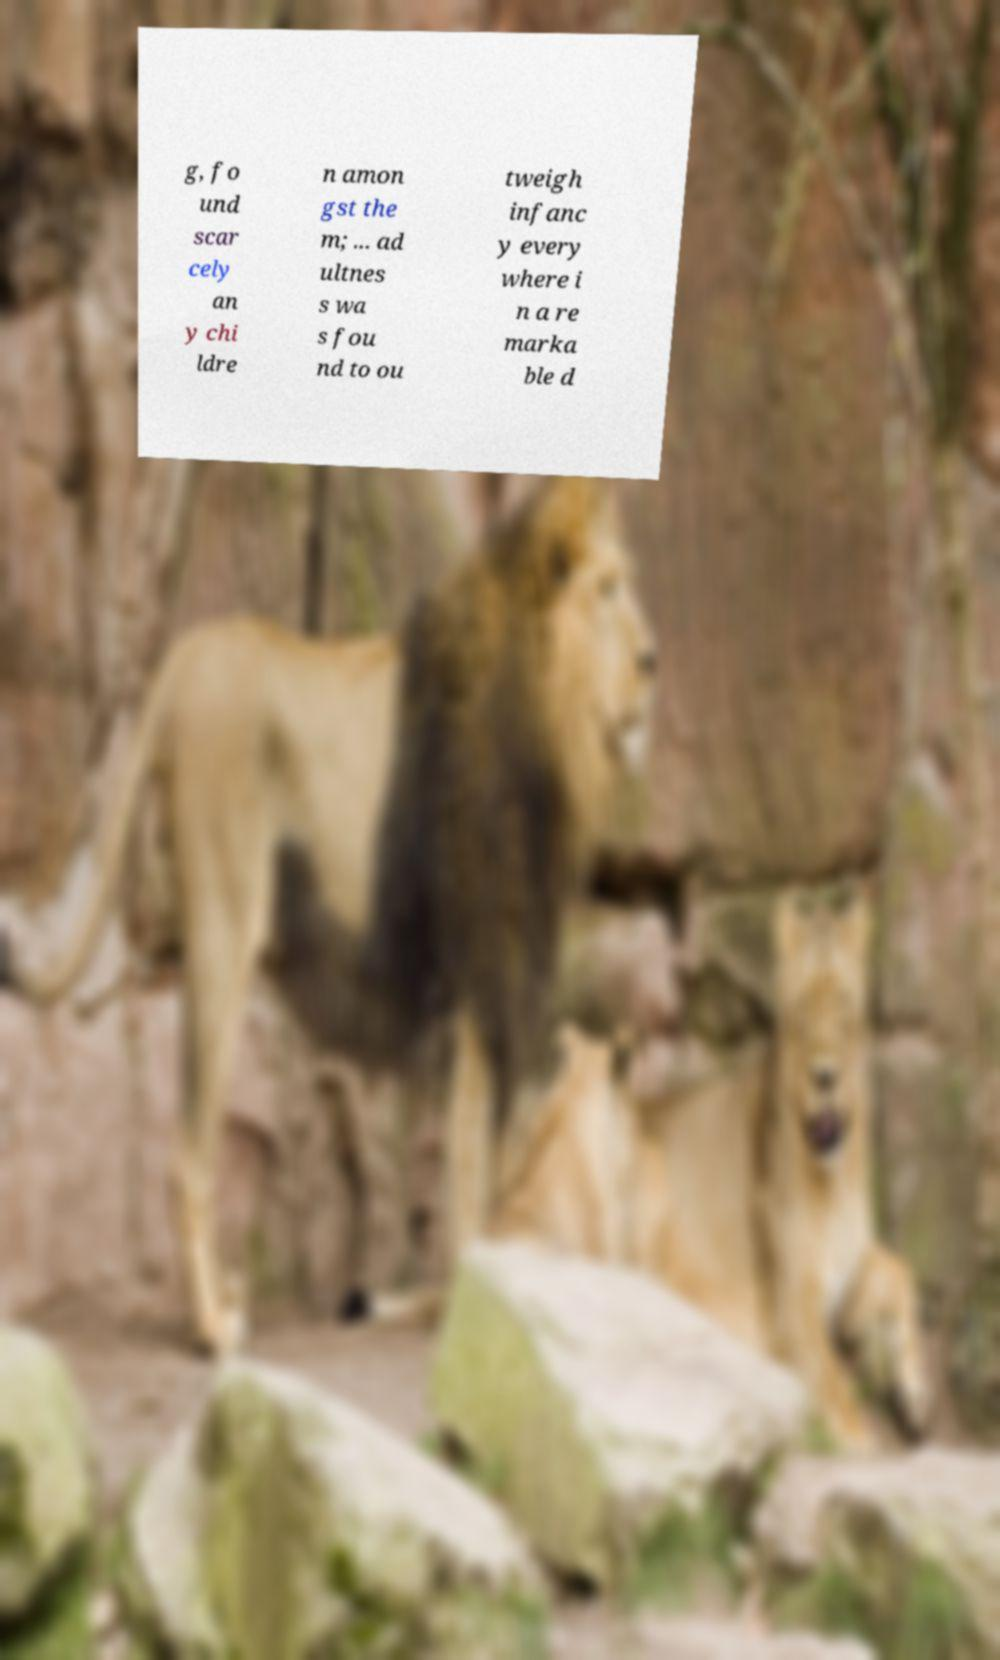Could you extract and type out the text from this image? g, fo und scar cely an y chi ldre n amon gst the m; ... ad ultnes s wa s fou nd to ou tweigh infanc y every where i n a re marka ble d 